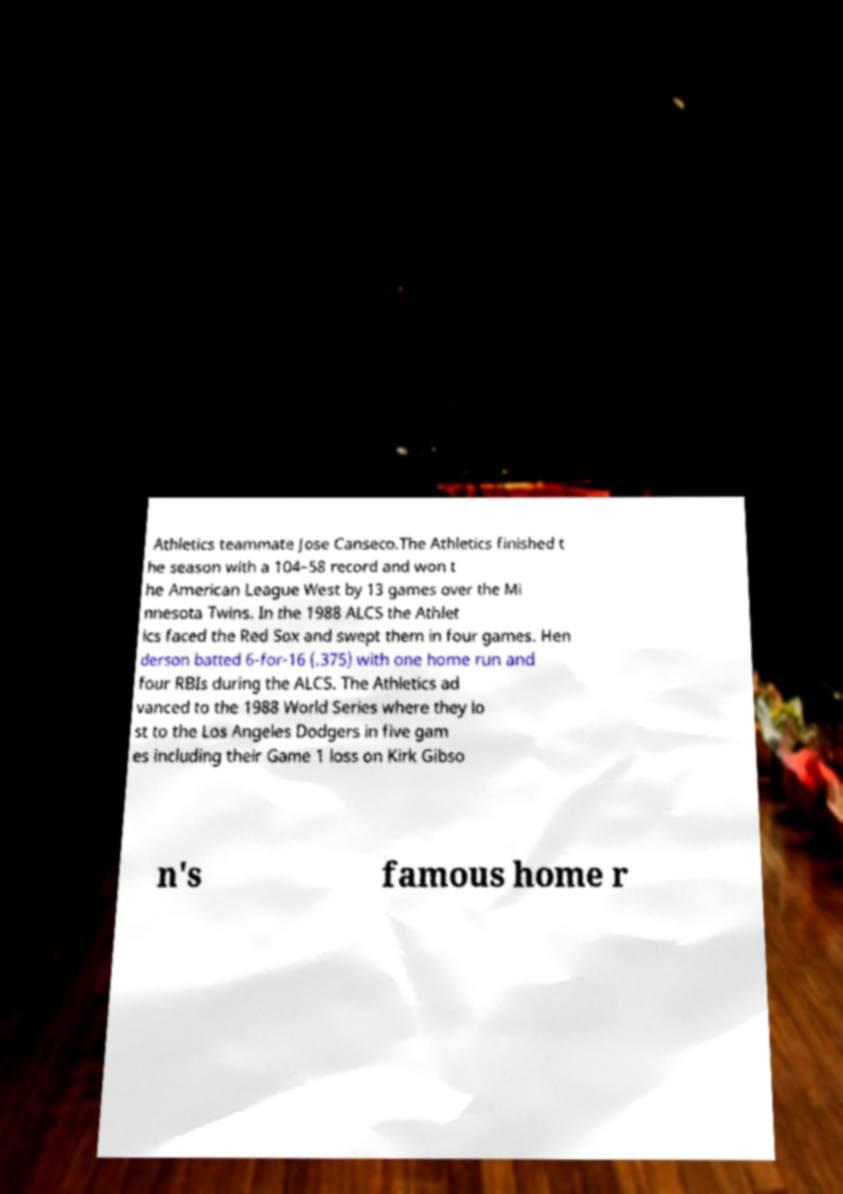Can you accurately transcribe the text from the provided image for me? Athletics teammate Jose Canseco.The Athletics finished t he season with a 104–58 record and won t he American League West by 13 games over the Mi nnesota Twins. In the 1988 ALCS the Athlet ics faced the Red Sox and swept them in four games. Hen derson batted 6-for-16 (.375) with one home run and four RBIs during the ALCS. The Athletics ad vanced to the 1988 World Series where they lo st to the Los Angeles Dodgers in five gam es including their Game 1 loss on Kirk Gibso n's famous home r 